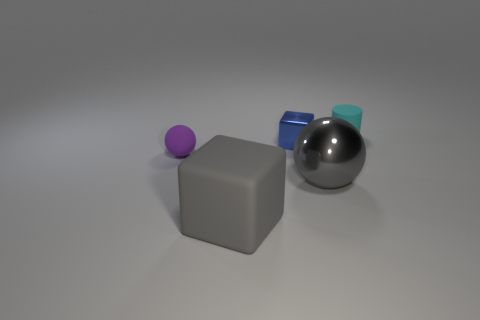Add 5 purple rubber balls. How many objects exist? 10 Subtract all cylinders. How many objects are left? 4 Subtract 0 green blocks. How many objects are left? 5 Subtract all cyan rubber cylinders. Subtract all cylinders. How many objects are left? 3 Add 1 tiny cylinders. How many tiny cylinders are left? 2 Add 1 gray matte things. How many gray matte things exist? 2 